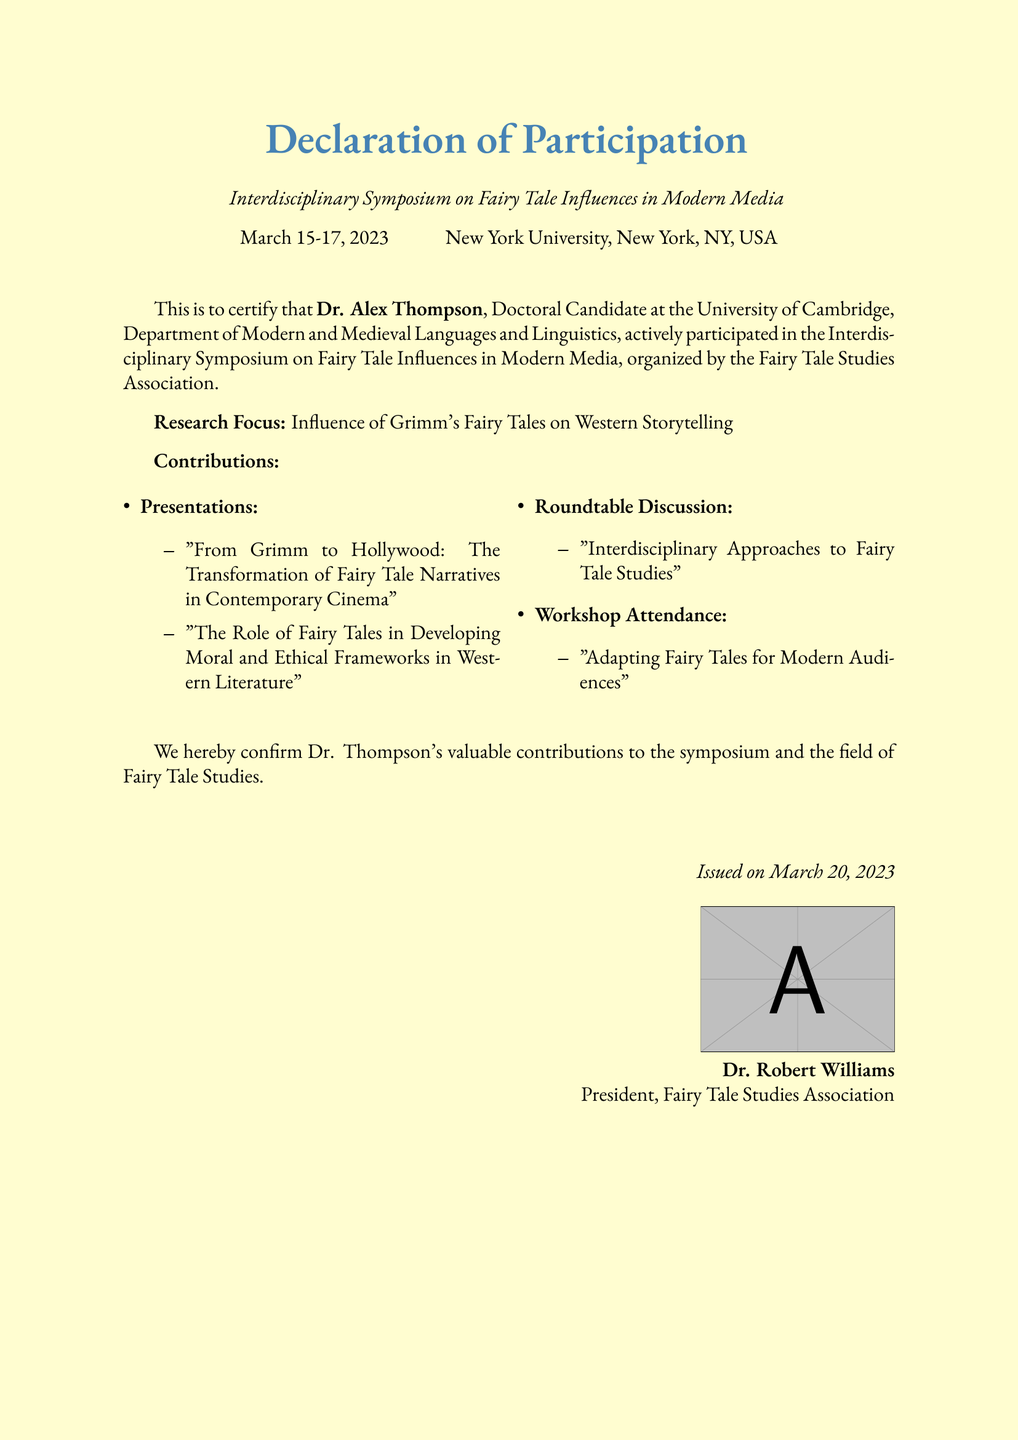What is the name of the participant? The document certifies the participation of Dr. Alex Thompson.
Answer: Dr. Alex Thompson What is the date of the symposium? The symposium took place from March 15 to March 17, 2023.
Answer: March 15-17, 2023 What is the location of the symposium? The symposium was held at New York University, New York, NY, USA.
Answer: New York University, New York, NY, USA What was Dr. Thompson's research focus? The document specifies that Dr. Thompson's research focus was the influence of Grimm's Fairy Tales on Western storytelling.
Answer: Influence of Grimm's Fairy Tales on Western Storytelling Who issued the declaration document? The declaration is issued by Dr. Robert Williams.
Answer: Dr. Robert Williams What type of discussion did Dr. Thompson participate in? The document mentions Dr. Thompson participated in a roundtable discussion.
Answer: Roundtable Discussion How many presentations did Dr. Thompson give? The document lists two presentations that Dr. Thompson delivered.
Answer: Two presentations When was the declaration issued? The document states that it was issued on March 20, 2023.
Answer: March 20, 2023 What is the title of one of Dr. Thompson's presentations? The document provides the title "From Grimm to Hollywood: The Transformation of Fairy Tale Narratives in Contemporary Cinema."
Answer: From Grimm to Hollywood: The Transformation of Fairy Tale Narratives in Contemporary Cinema 